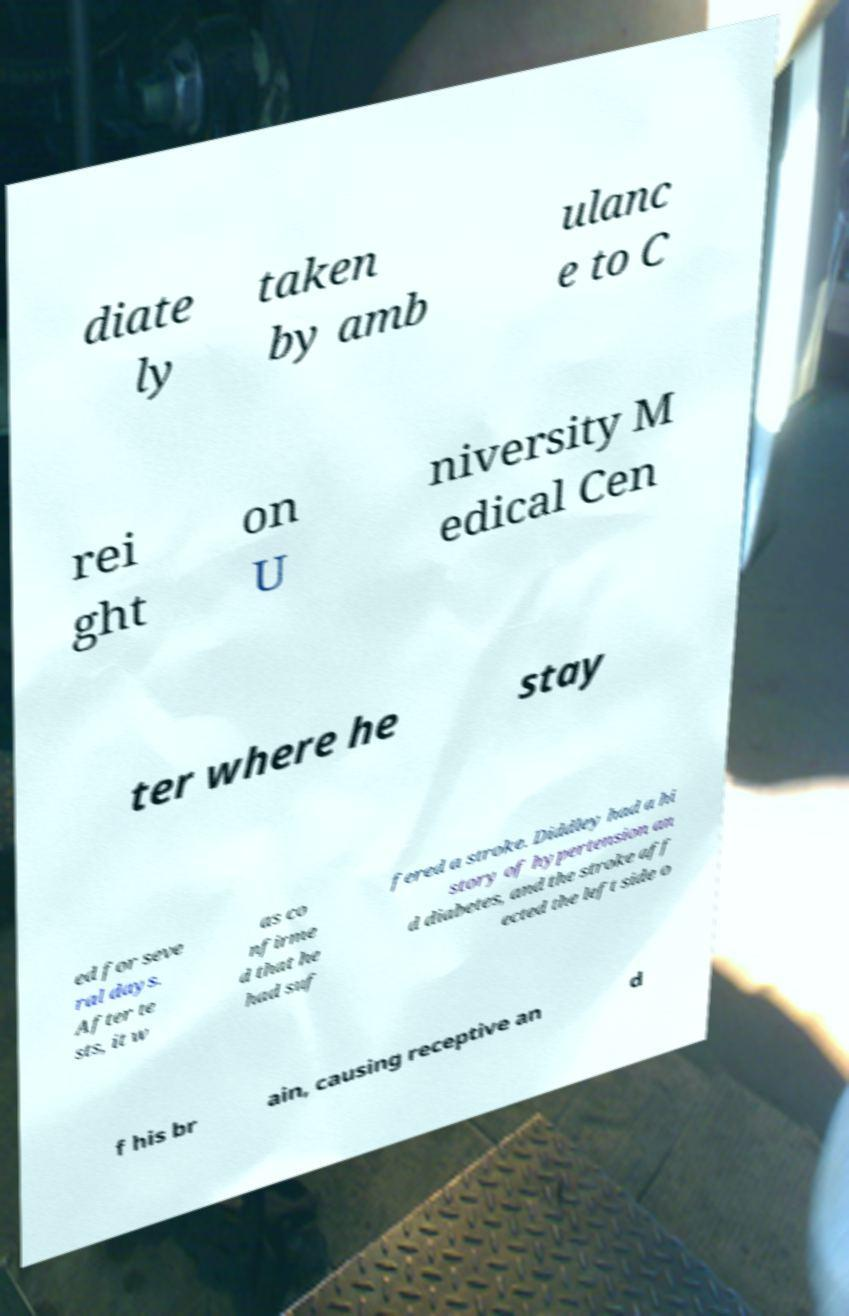There's text embedded in this image that I need extracted. Can you transcribe it verbatim? diate ly taken by amb ulanc e to C rei ght on U niversity M edical Cen ter where he stay ed for seve ral days. After te sts, it w as co nfirme d that he had suf fered a stroke. Diddley had a hi story of hypertension an d diabetes, and the stroke aff ected the left side o f his br ain, causing receptive an d 